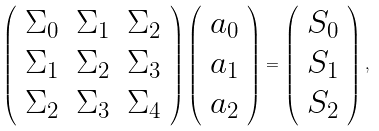Convert formula to latex. <formula><loc_0><loc_0><loc_500><loc_500>\left ( \begin{array} { c c c } \Sigma _ { 0 } & \Sigma _ { 1 } & \Sigma _ { 2 } \\ \Sigma _ { 1 } & \Sigma _ { 2 } & \Sigma _ { 3 } \\ \Sigma _ { 2 } & \Sigma _ { 3 } & \Sigma _ { 4 } \end{array} \right ) \left ( \begin{array} { c } a _ { 0 } \\ a _ { 1 } \\ a _ { 2 } \end{array} \right ) = \left ( \begin{array} { c } S _ { 0 } \\ S _ { 1 } \\ S _ { 2 } \end{array} \right ) ,</formula> 